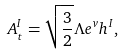<formula> <loc_0><loc_0><loc_500><loc_500>A _ { t } ^ { I } = \sqrt { \frac { 3 } { 2 } } \Lambda e ^ { v } h ^ { I } ,</formula> 